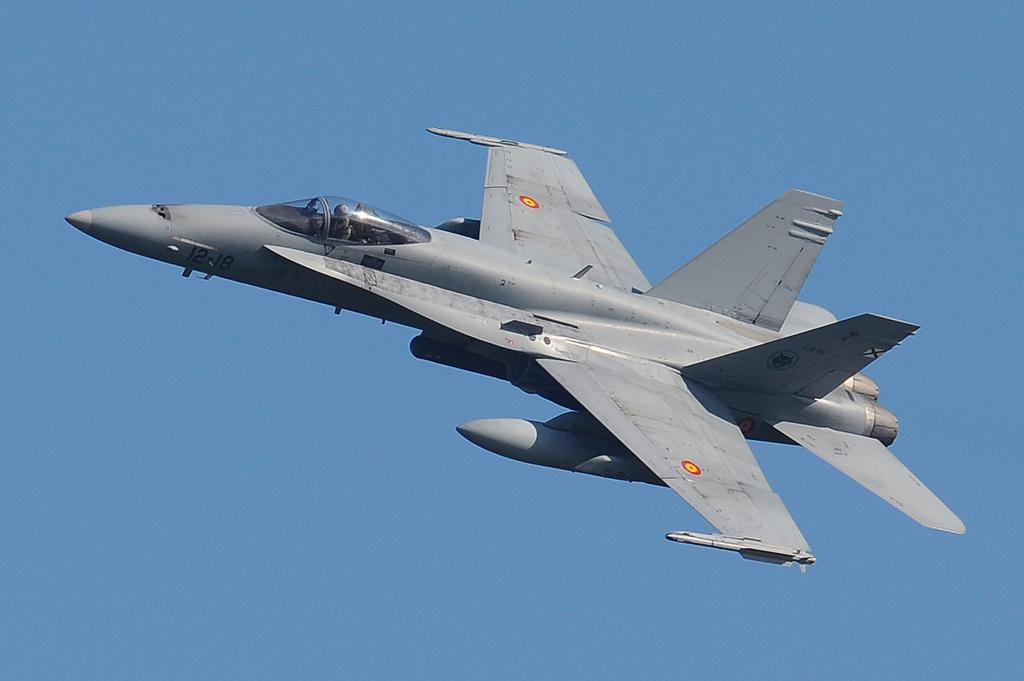What is the main subject of the image? The main subject of the image is a flying jet. Can you describe the jet's location in the image? The jet is in the air in the image. What else can be seen in the image besides the jet? The sky is visible in the image. What type of idea is being discussed by the lawyer in the image? There is no lawyer or idea present in the image; it only features a flying jet and the sky. 